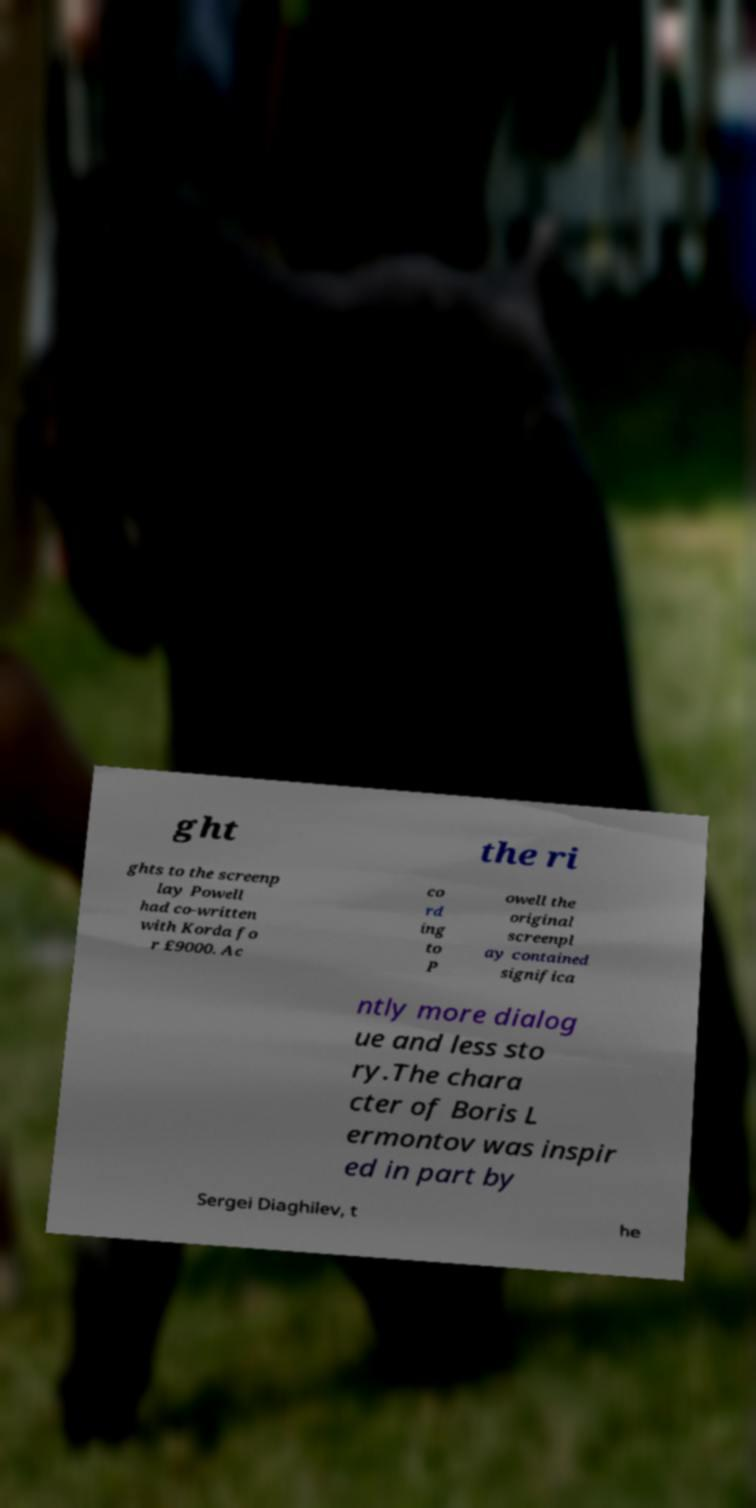There's text embedded in this image that I need extracted. Can you transcribe it verbatim? ght the ri ghts to the screenp lay Powell had co-written with Korda fo r £9000. Ac co rd ing to P owell the original screenpl ay contained significa ntly more dialog ue and less sto ry.The chara cter of Boris L ermontov was inspir ed in part by Sergei Diaghilev, t he 